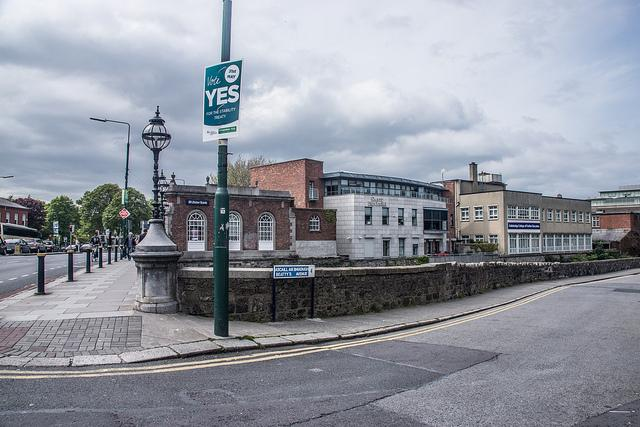What weather might be imminent here? rain 